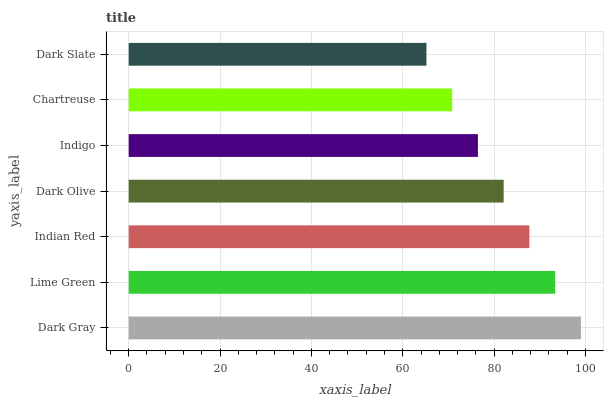Is Dark Slate the minimum?
Answer yes or no. Yes. Is Dark Gray the maximum?
Answer yes or no. Yes. Is Lime Green the minimum?
Answer yes or no. No. Is Lime Green the maximum?
Answer yes or no. No. Is Dark Gray greater than Lime Green?
Answer yes or no. Yes. Is Lime Green less than Dark Gray?
Answer yes or no. Yes. Is Lime Green greater than Dark Gray?
Answer yes or no. No. Is Dark Gray less than Lime Green?
Answer yes or no. No. Is Dark Olive the high median?
Answer yes or no. Yes. Is Dark Olive the low median?
Answer yes or no. Yes. Is Dark Slate the high median?
Answer yes or no. No. Is Indian Red the low median?
Answer yes or no. No. 